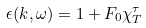<formula> <loc_0><loc_0><loc_500><loc_500>\epsilon ( { k } , \omega ) = 1 + F _ { 0 } \chi _ { T } ^ { \tau }</formula> 